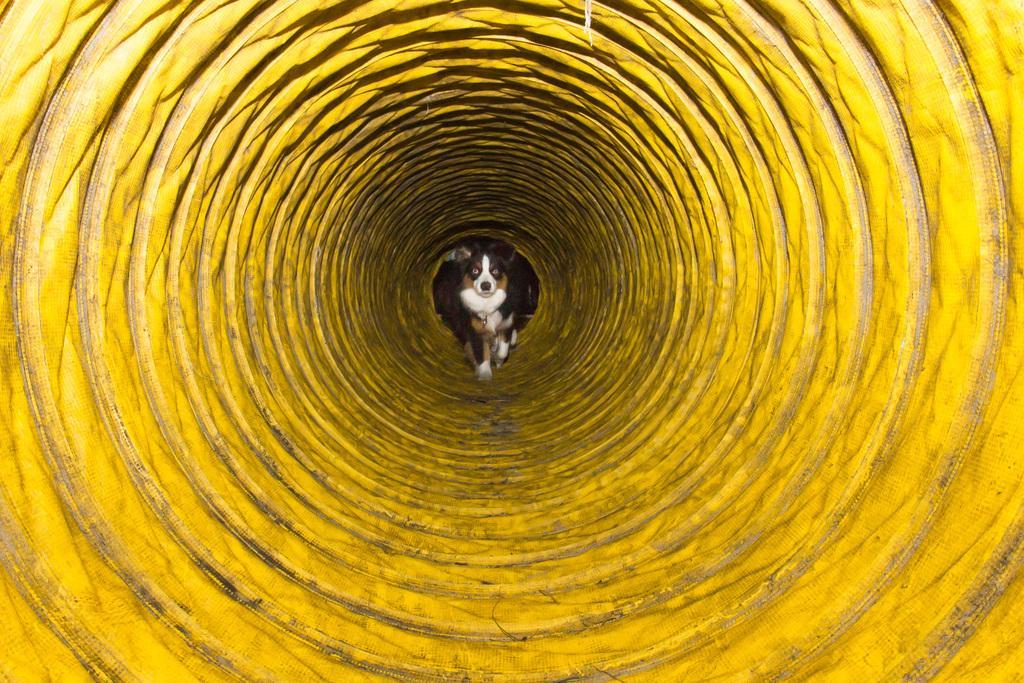Please provide a concise description of this image. In this picture I can see a dog is sitting in a yellow color well. 